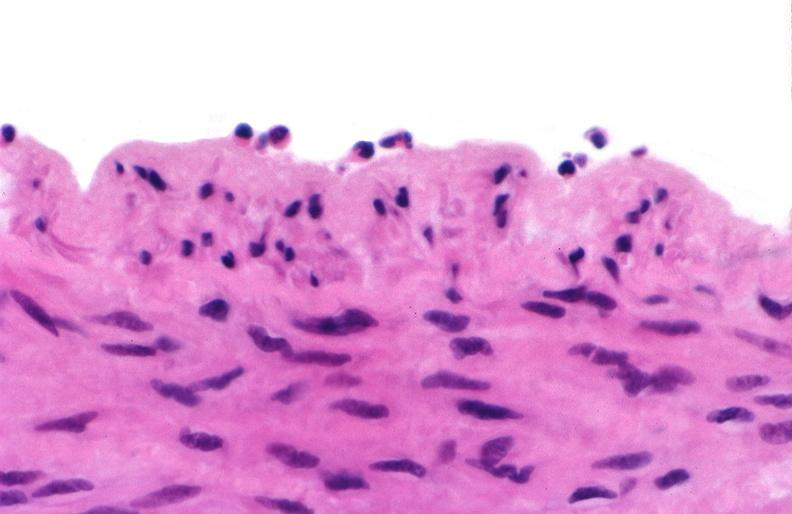what is present?
Answer the question using a single word or phrase. Cardiovascular 